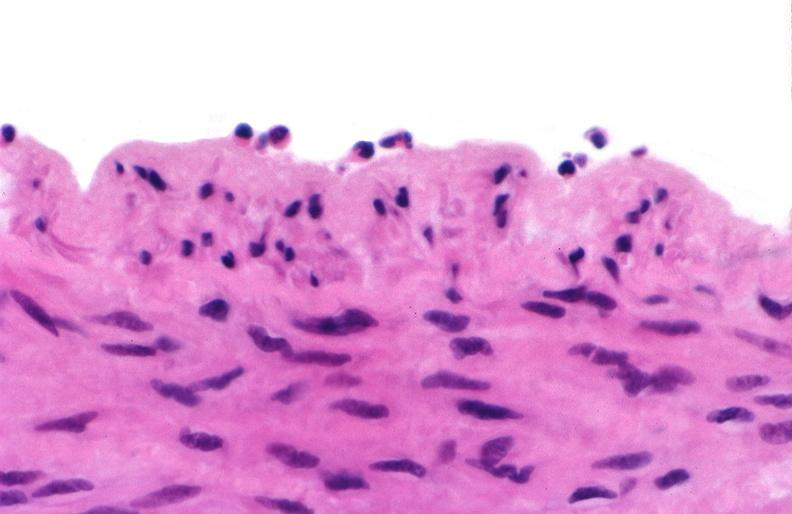what is present?
Answer the question using a single word or phrase. Cardiovascular 